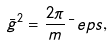<formula> <loc_0><loc_0><loc_500><loc_500>\bar { g } ^ { 2 } = \frac { 2 \pi } m \bar { \ } e p s ,</formula> 